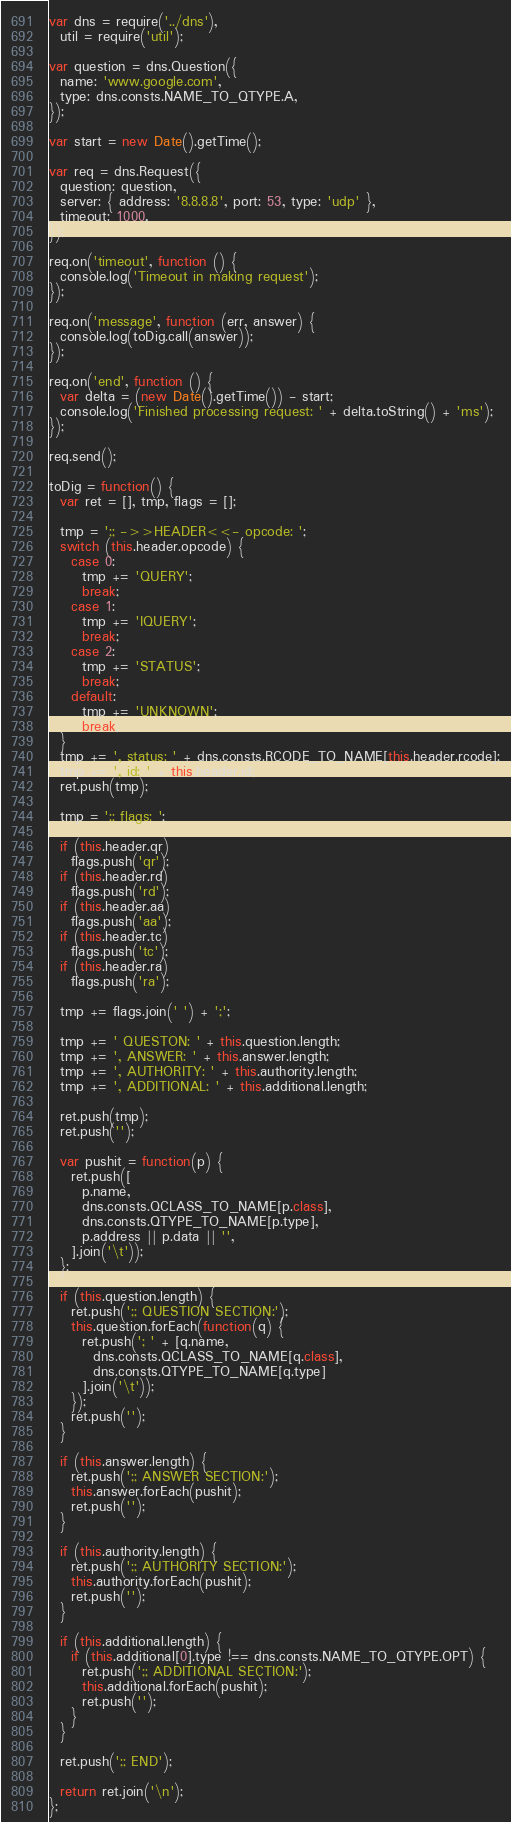<code> <loc_0><loc_0><loc_500><loc_500><_JavaScript_>var dns = require('../dns'),
  util = require('util');

var question = dns.Question({
  name: 'www.google.com',
  type: dns.consts.NAME_TO_QTYPE.A,
});

var start = new Date().getTime();

var req = dns.Request({
  question: question,
  server: { address: '8.8.8.8', port: 53, type: 'udp' },
  timeout: 1000,
});

req.on('timeout', function () {
  console.log('Timeout in making request');
});

req.on('message', function (err, answer) {
  console.log(toDig.call(answer));
});

req.on('end', function () {
  var delta = (new Date().getTime()) - start;
  console.log('Finished processing request: ' + delta.toString() + 'ms');
});

req.send();

toDig = function() {
  var ret = [], tmp, flags = [];

  tmp = ';; ->>HEADER<<- opcode: ';
  switch (this.header.opcode) {
    case 0:
      tmp += 'QUERY';
      break;
    case 1:
      tmp += 'IQUERY';
      break;
    case 2:
      tmp += 'STATUS';
      break;
    default:
      tmp += 'UNKNOWN';
      break;
  }
  tmp += ', status: ' + dns.consts.RCODE_TO_NAME[this.header.rcode];
  tmp += ', id: ' + this.header.id;
  ret.push(tmp);

  tmp = ';; flags: ';

  if (this.header.qr)
    flags.push('qr');
  if (this.header.rd)
    flags.push('rd');
  if (this.header.aa)
    flags.push('aa');
  if (this.header.tc)
    flags.push('tc');
  if (this.header.ra)
    flags.push('ra');

  tmp += flags.join(' ') + ';';

  tmp += ' QUESTON: ' + this.question.length;
  tmp += ', ANSWER: ' + this.answer.length;
  tmp += ', AUTHORITY: ' + this.authority.length;
  tmp += ', ADDITIONAL: ' + this.additional.length;

  ret.push(tmp);
  ret.push('');

  var pushit = function(p) {
    ret.push([
      p.name,
      dns.consts.QCLASS_TO_NAME[p.class],
      dns.consts.QTYPE_TO_NAME[p.type],
      p.address || p.data || '',
    ].join('\t'));
  };

  if (this.question.length) {
    ret.push(';; QUESTION SECTION:');
    this.question.forEach(function(q) {
      ret.push('; ' + [q.name,
        dns.consts.QCLASS_TO_NAME[q.class],
        dns.consts.QTYPE_TO_NAME[q.type]
      ].join('\t'));
    });
    ret.push('');
  }

  if (this.answer.length) {
    ret.push(';; ANSWER SECTION:');
    this.answer.forEach(pushit);
    ret.push('');
  }

  if (this.authority.length) {
    ret.push(';; AUTHORITY SECTION:');
    this.authority.forEach(pushit);
    ret.push('');
  }

  if (this.additional.length) {
    if (this.additional[0].type !== dns.consts.NAME_TO_QTYPE.OPT) {
      ret.push(';; ADDITIONAL SECTION:');
      this.additional.forEach(pushit);
      ret.push('');
    }
  }

  ret.push(';; END');

  return ret.join('\n');
};

</code> 